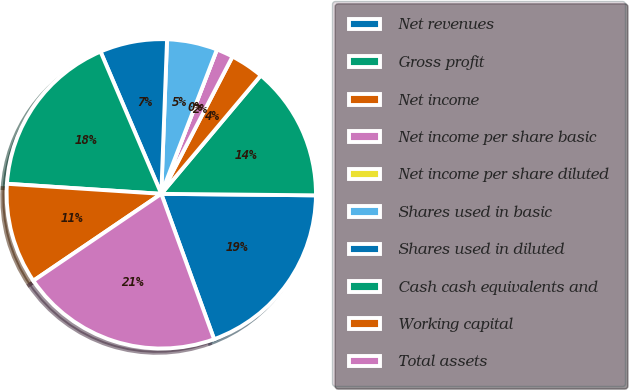<chart> <loc_0><loc_0><loc_500><loc_500><pie_chart><fcel>Net revenues<fcel>Gross profit<fcel>Net income<fcel>Net income per share basic<fcel>Net income per share diluted<fcel>Shares used in basic<fcel>Shares used in diluted<fcel>Cash cash equivalents and<fcel>Working capital<fcel>Total assets<nl><fcel>19.3%<fcel>14.03%<fcel>3.51%<fcel>1.76%<fcel>0.0%<fcel>5.26%<fcel>7.02%<fcel>17.54%<fcel>10.53%<fcel>21.05%<nl></chart> 